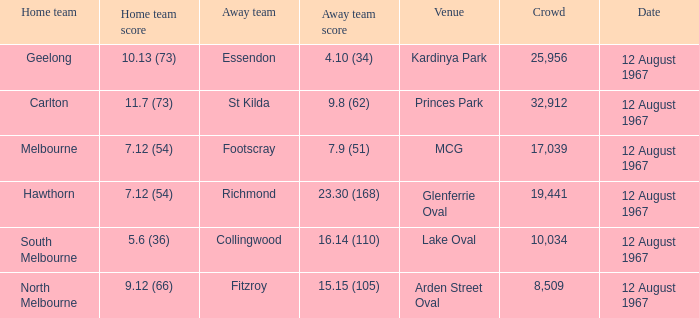What is the date of the game between Melbourne and Footscray? 12 August 1967. 